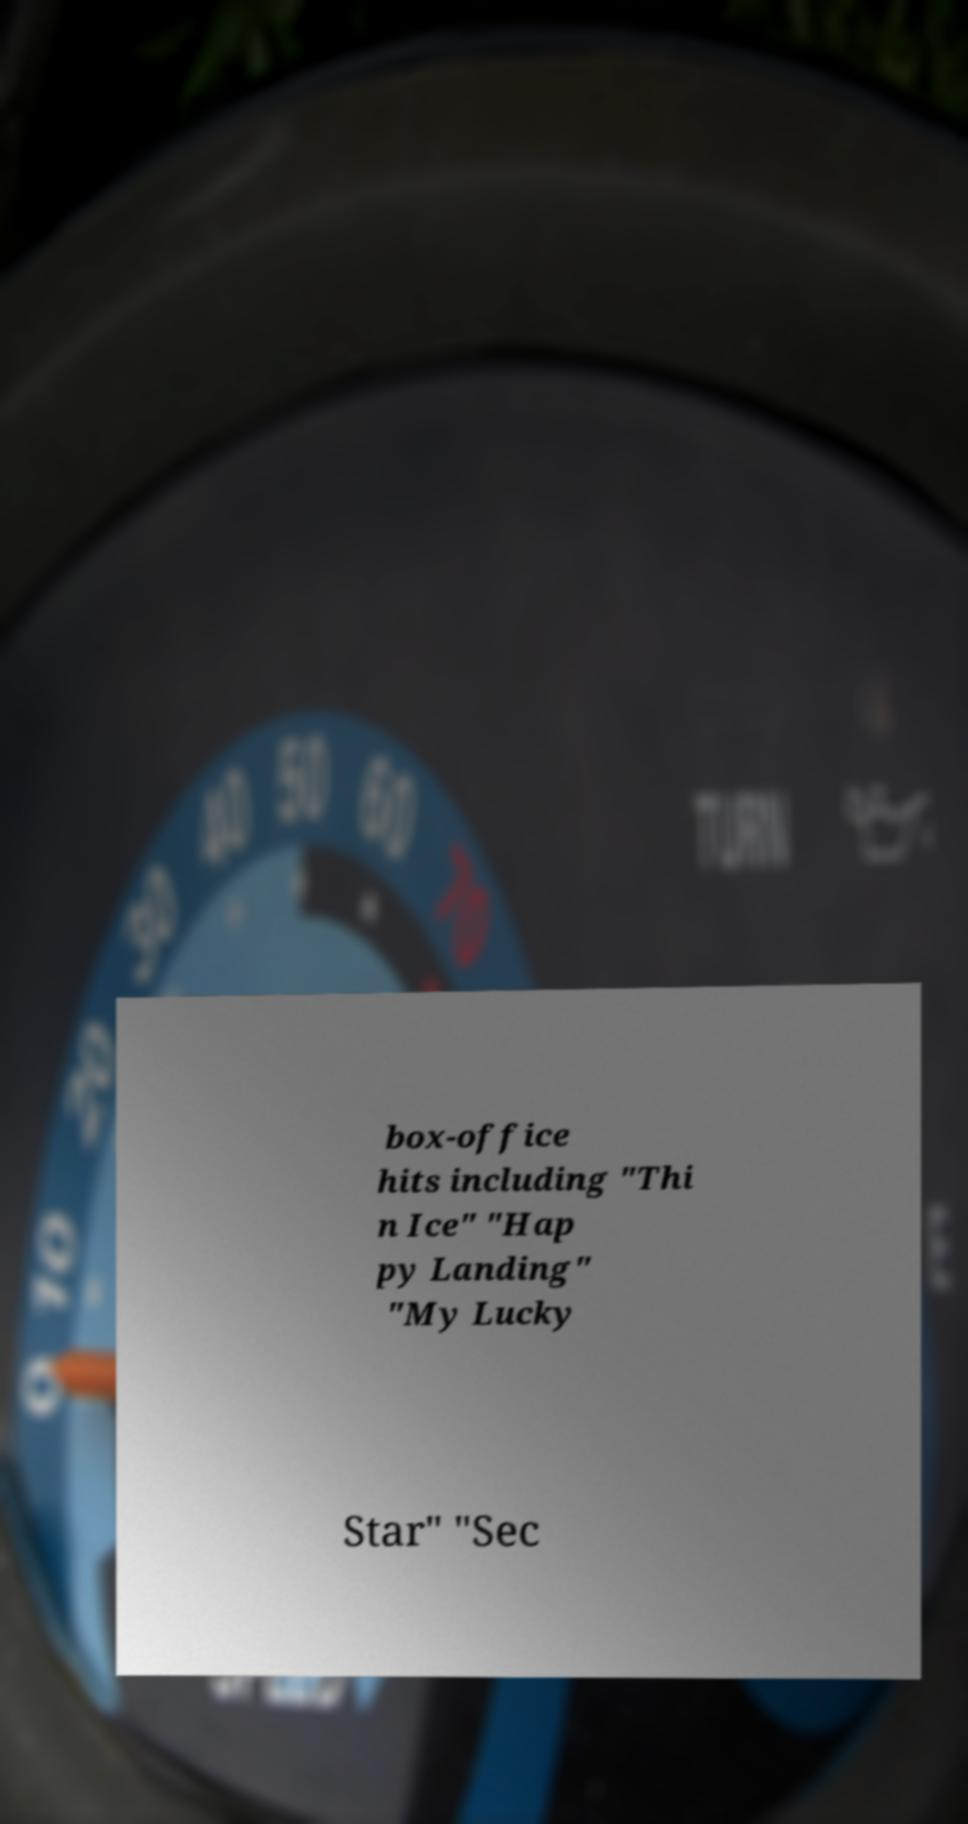What messages or text are displayed in this image? I need them in a readable, typed format. box-office hits including "Thi n Ice" "Hap py Landing" "My Lucky Star" "Sec 